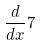Convert formula to latex. <formula><loc_0><loc_0><loc_500><loc_500>\frac { d } { d x } 7</formula> 